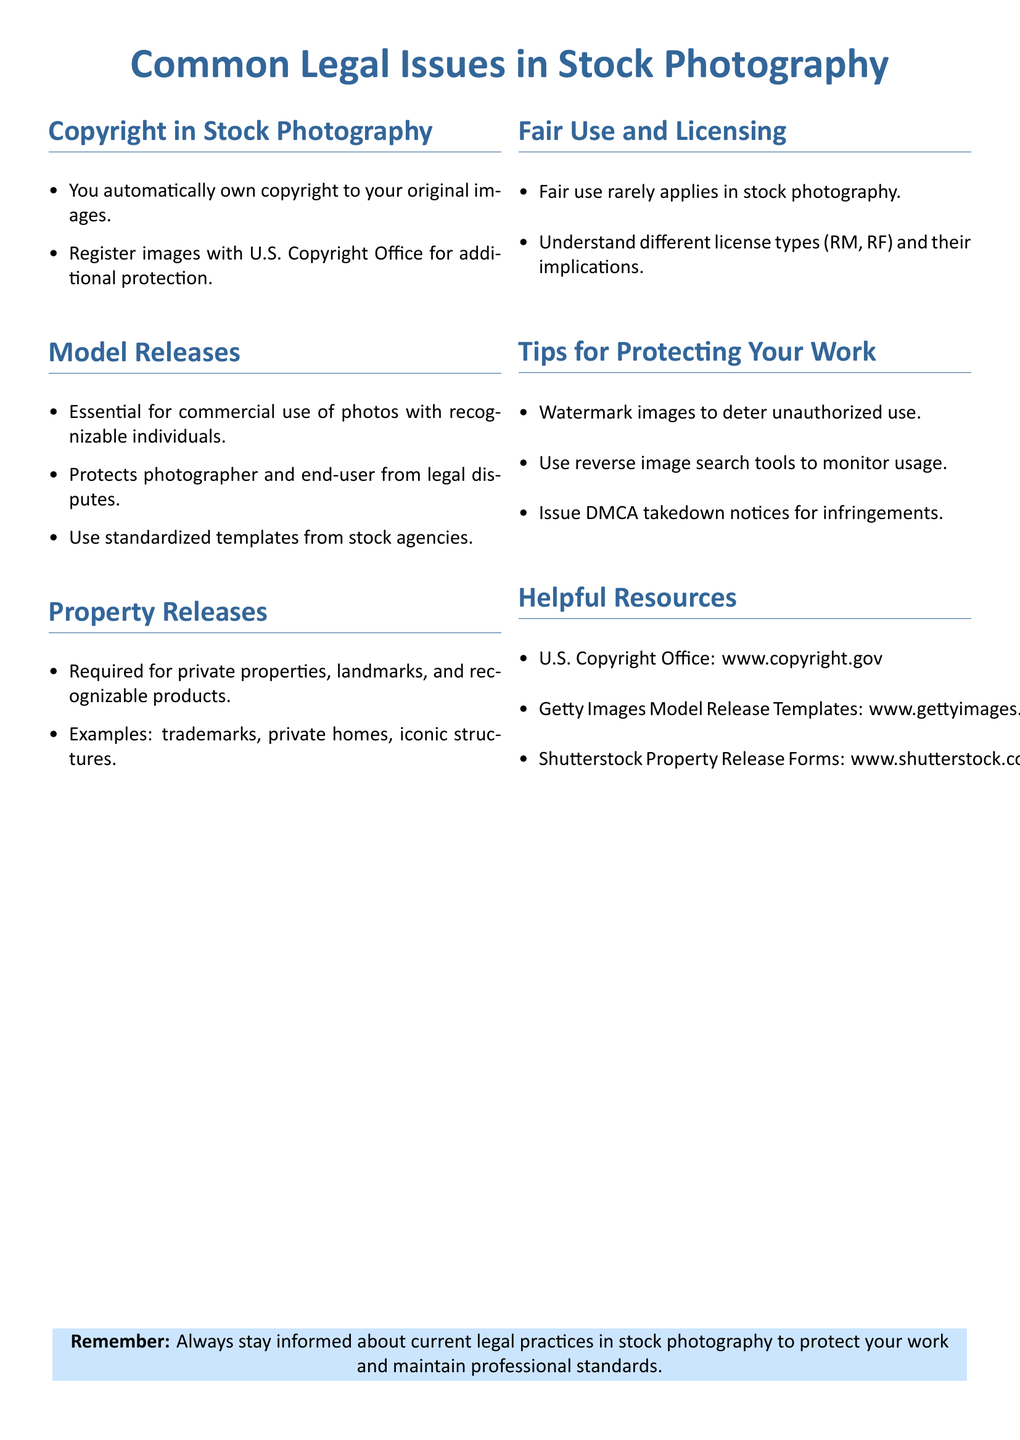What is automatically owned by photographers? The document states that photographers automatically own copyright to their original images.
Answer: Copyright What must be registered for additional protection? It mentions that registering images with the U.S. Copyright Office provides additional protection.
Answer: U.S. Copyright Office What is essential for commercial use of photos? The document emphasizes that model releases are essential for commercial use of photos with recognizable individuals.
Answer: Model releases What type of release is required for recognizable products? It specifies that property releases are required for private properties, landmarks, and recognizable products.
Answer: Property releases How can photographers monitor unauthorized usage? The document suggests using reverse image search tools to monitor usage of their images.
Answer: Reverse image search tools What is the advised action for infringements? It states that issuing DMCA takedown notices is the recommended action for infringements.
Answer: DMCA takedown notices What does fair use rarely apply to? According to the document, fair use rarely applies in stock photography.
Answer: Stock photography Which website is listed for copyright resources? The U.S. Copyright Office is listed as a helpful resource in the document.
Answer: www.copyright.gov What should photographers remember regarding legal practices? The fact sheet advises photographers to stay informed about current legal practices in stock photography.
Answer: Current legal practices 